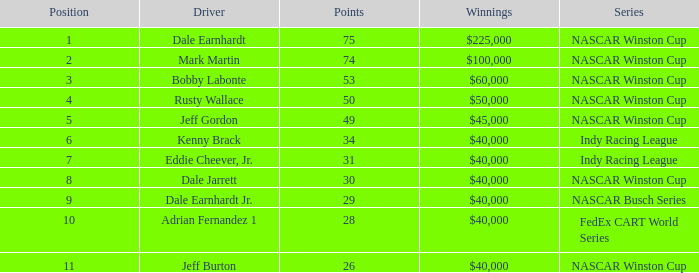What was the ranking of the driver who secured a $60,000 prize? 3.0. 